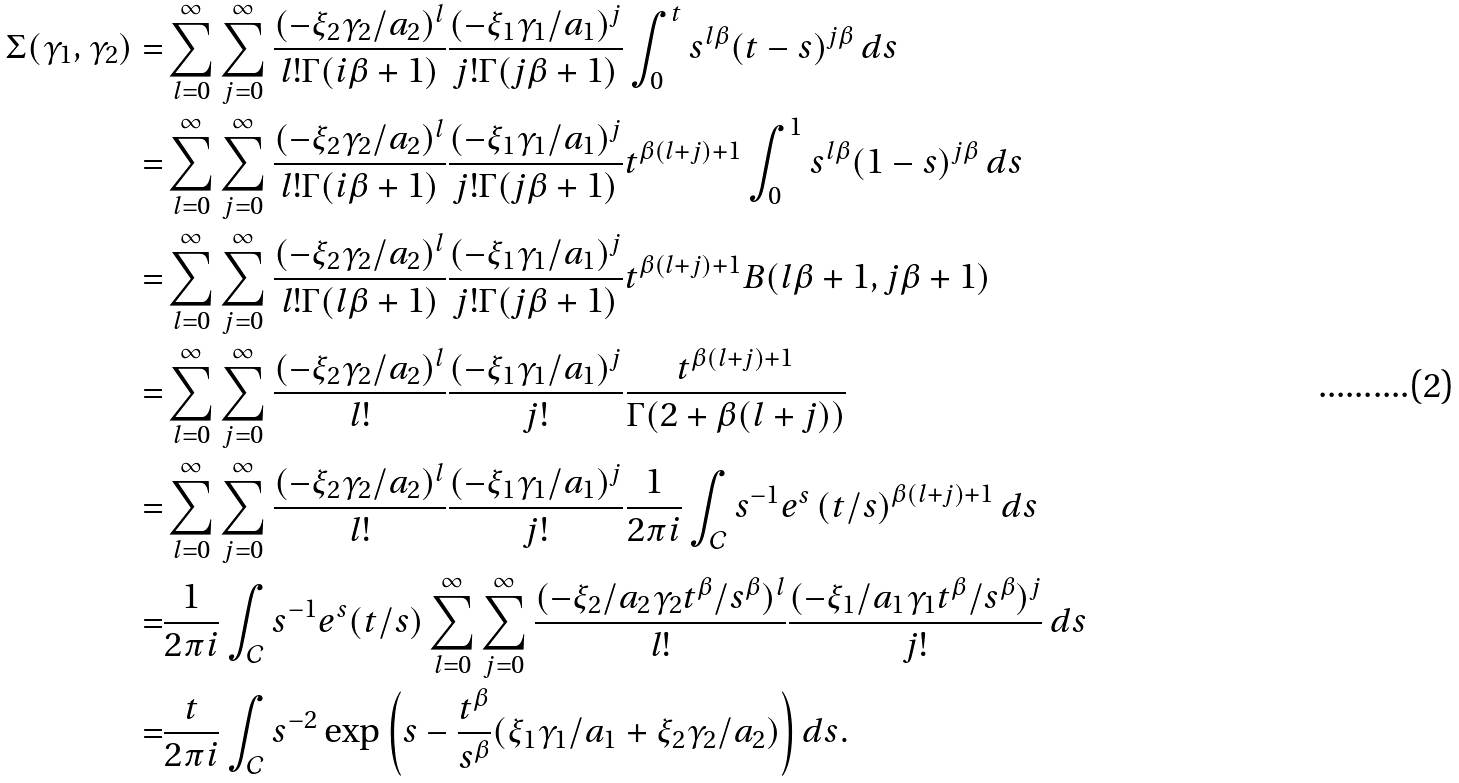Convert formula to latex. <formula><loc_0><loc_0><loc_500><loc_500>\Sigma ( \gamma _ { 1 } , \gamma _ { 2 } ) = & \sum _ { l = 0 } ^ { \infty } \sum _ { j = 0 } ^ { \infty } \frac { ( - \xi _ { 2 } \gamma _ { 2 } / a _ { 2 } ) ^ { l } } { l ! \Gamma ( i \beta + 1 ) } \frac { ( - \xi _ { 1 } \gamma _ { 1 } / a _ { 1 } ) ^ { j } } { j ! \Gamma ( j \beta + 1 ) } \int _ { 0 } ^ { t } s ^ { l \beta } ( t - s ) ^ { j \beta } \, d s \\ = & \sum _ { l = 0 } ^ { \infty } \sum _ { j = 0 } ^ { \infty } \frac { ( - \xi _ { 2 } \gamma _ { 2 } / a _ { 2 } ) ^ { l } } { l ! \Gamma ( i \beta + 1 ) } \frac { ( - \xi _ { 1 } \gamma _ { 1 } / a _ { 1 } ) ^ { j } } { j ! \Gamma ( j \beta + 1 ) } t ^ { \beta ( l + j ) + 1 } \int _ { 0 } ^ { 1 } s ^ { l \beta } ( 1 - s ) ^ { j \beta } \, d s \\ = & \sum _ { l = 0 } ^ { \infty } \sum _ { j = 0 } ^ { \infty } \frac { ( - \xi _ { 2 } \gamma _ { 2 } / a _ { 2 } ) ^ { l } } { l ! \Gamma ( l \beta + 1 ) } \frac { ( - \xi _ { 1 } \gamma _ { 1 } / a _ { 1 } ) ^ { j } } { j ! \Gamma ( j \beta + 1 ) } t ^ { \beta ( l + j ) + 1 } B ( l \beta + 1 , j \beta + 1 ) \\ = & \sum _ { l = 0 } ^ { \infty } \sum _ { j = 0 } ^ { \infty } \frac { ( - \xi _ { 2 } \gamma _ { 2 } / a _ { 2 } ) ^ { l } } { l ! } \frac { ( - \xi _ { 1 } \gamma _ { 1 } / a _ { 1 } ) ^ { j } } { j ! } \frac { t ^ { \beta ( l + j ) + 1 } } { \Gamma ( 2 + \beta ( l + j ) ) } \\ = & \sum _ { l = 0 } ^ { \infty } \sum _ { j = 0 } ^ { \infty } \frac { ( - \xi _ { 2 } \gamma _ { 2 } / a _ { 2 } ) ^ { l } } { l ! } \frac { ( - \xi _ { 1 } \gamma _ { 1 } / a _ { 1 } ) ^ { j } } { j ! } \frac { 1 } { 2 \pi i } \int _ { \mathcal { C } } s ^ { - 1 } e ^ { s } \left ( t / s \right ) ^ { \beta ( l + j ) + 1 } d s \\ = & \frac { 1 } { 2 \pi i } \int _ { \mathcal { C } } s ^ { - 1 } e ^ { s } ( t / s ) \sum _ { l = 0 } ^ { \infty } \sum _ { j = 0 } ^ { \infty } \frac { ( - \xi _ { 2 } / a _ { 2 } \gamma _ { 2 } t ^ { \beta } / s ^ { \beta } ) ^ { l } } { l ! } \frac { ( - \xi _ { 1 } / a _ { 1 } \gamma _ { 1 } t ^ { \beta } / s ^ { \beta } ) ^ { j } } { j ! } \, d s \\ = & \frac { t } { 2 \pi i } \int _ { \mathcal { C } } s ^ { - 2 } \exp \left ( s - \frac { t ^ { \beta } } { s ^ { \beta } } ( \xi _ { 1 } \gamma _ { 1 } / a _ { 1 } + \xi _ { 2 } \gamma _ { 2 } / a _ { 2 } ) \right ) d s .</formula> 